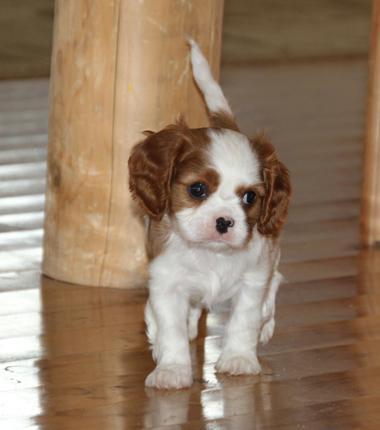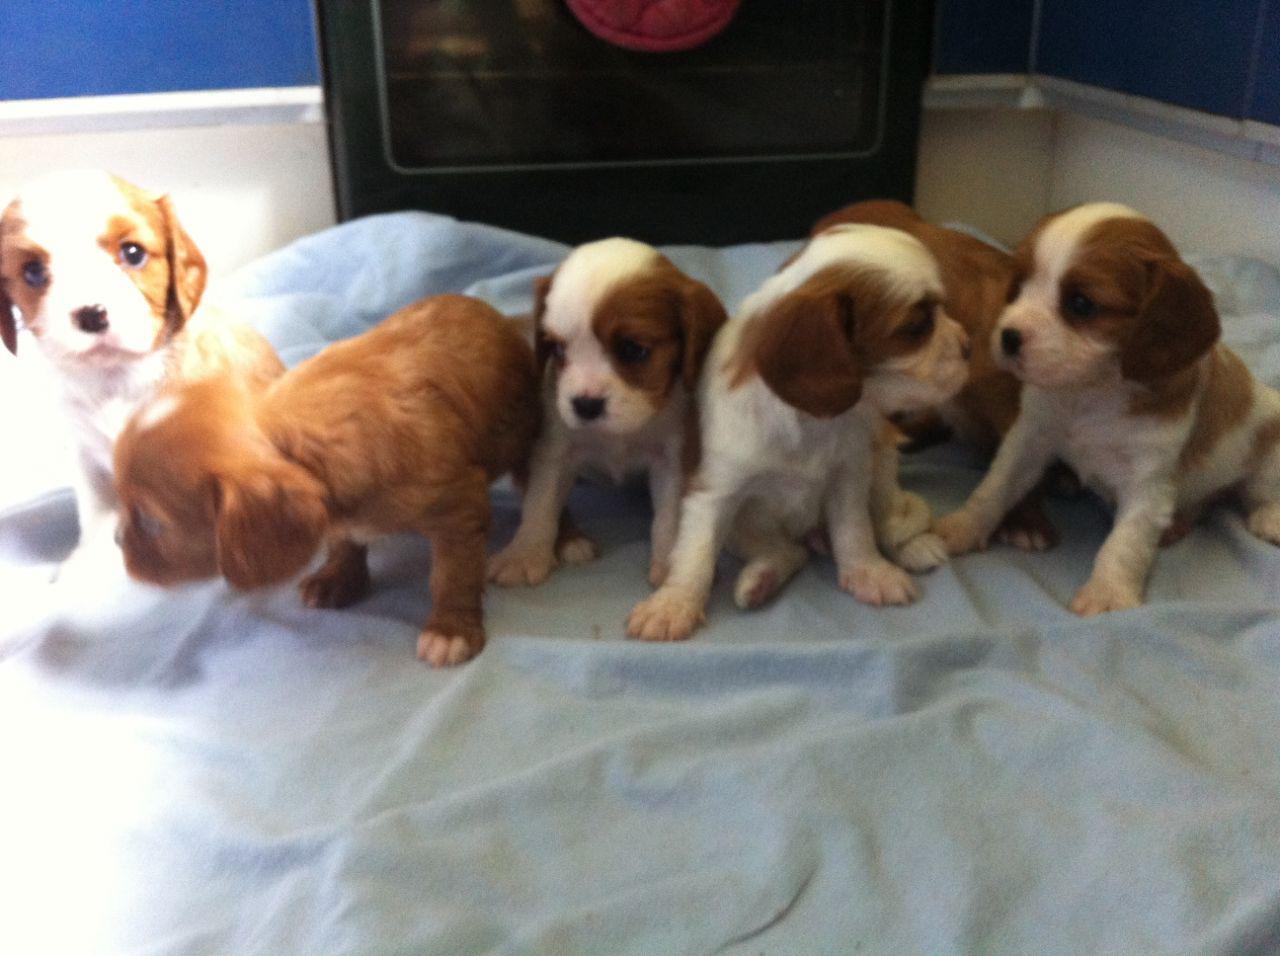The first image is the image on the left, the second image is the image on the right. Analyze the images presented: Is the assertion "There are no more than three dogs." valid? Answer yes or no. No. The first image is the image on the left, the second image is the image on the right. Analyze the images presented: Is the assertion "There are no more than three dogs." valid? Answer yes or no. No. 